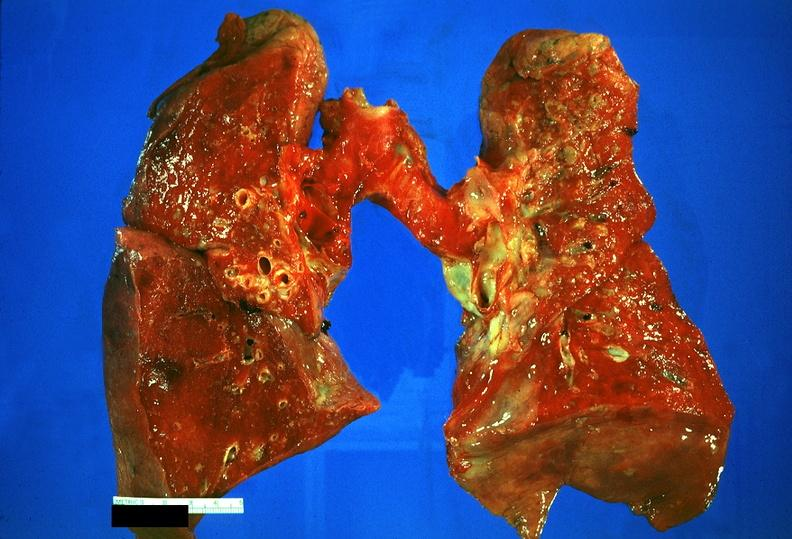what does this image show?
Answer the question using a single word or phrase. Lung 